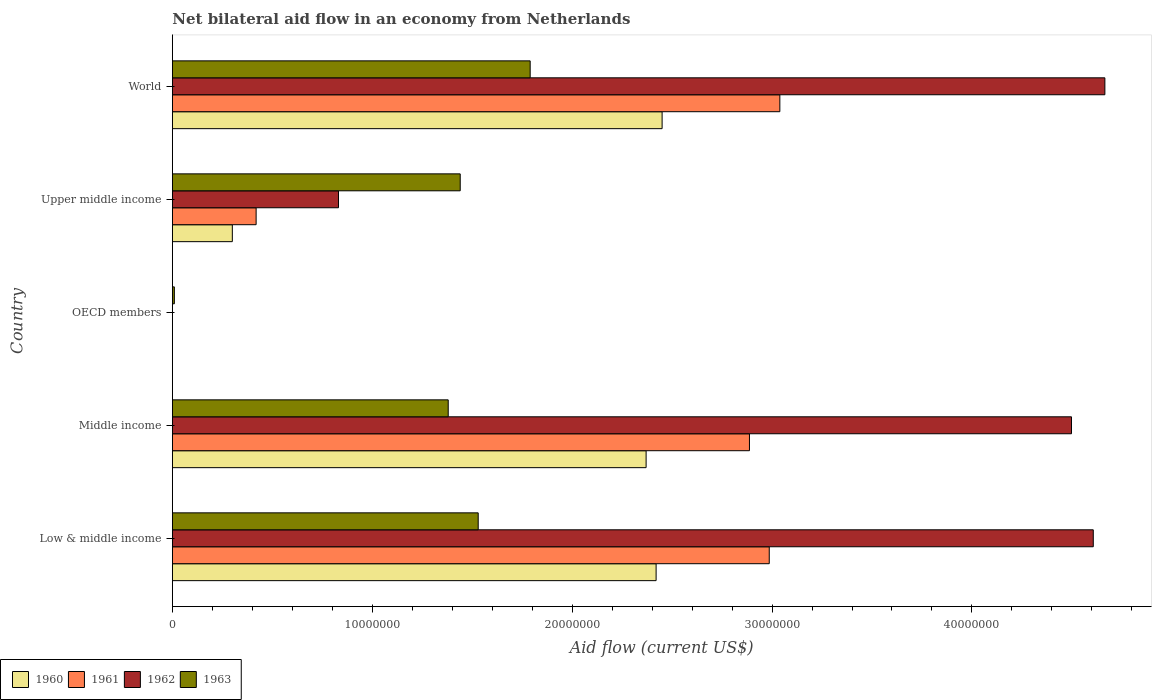How many different coloured bars are there?
Provide a short and direct response. 4. How many bars are there on the 5th tick from the top?
Your answer should be compact. 4. In how many cases, is the number of bars for a given country not equal to the number of legend labels?
Offer a very short reply. 1. What is the net bilateral aid flow in 1960 in OECD members?
Keep it short and to the point. 0. Across all countries, what is the maximum net bilateral aid flow in 1963?
Ensure brevity in your answer.  1.79e+07. Across all countries, what is the minimum net bilateral aid flow in 1963?
Ensure brevity in your answer.  1.00e+05. In which country was the net bilateral aid flow in 1963 maximum?
Provide a succinct answer. World. What is the total net bilateral aid flow in 1961 in the graph?
Give a very brief answer. 9.33e+07. What is the difference between the net bilateral aid flow in 1961 in Low & middle income and that in Middle income?
Give a very brief answer. 9.90e+05. What is the difference between the net bilateral aid flow in 1963 in World and the net bilateral aid flow in 1962 in Low & middle income?
Ensure brevity in your answer.  -2.82e+07. What is the average net bilateral aid flow in 1961 per country?
Offer a terse response. 1.87e+07. What is the difference between the net bilateral aid flow in 1963 and net bilateral aid flow in 1961 in Low & middle income?
Your answer should be compact. -1.46e+07. In how many countries, is the net bilateral aid flow in 1960 greater than 2000000 US$?
Provide a succinct answer. 4. What is the ratio of the net bilateral aid flow in 1962 in Low & middle income to that in World?
Ensure brevity in your answer.  0.99. Is the difference between the net bilateral aid flow in 1963 in Low & middle income and Middle income greater than the difference between the net bilateral aid flow in 1961 in Low & middle income and Middle income?
Keep it short and to the point. Yes. What is the difference between the highest and the second highest net bilateral aid flow in 1963?
Your answer should be compact. 2.60e+06. What is the difference between the highest and the lowest net bilateral aid flow in 1962?
Provide a short and direct response. 4.66e+07. In how many countries, is the net bilateral aid flow in 1963 greater than the average net bilateral aid flow in 1963 taken over all countries?
Offer a terse response. 4. Is the sum of the net bilateral aid flow in 1961 in Low & middle income and Middle income greater than the maximum net bilateral aid flow in 1962 across all countries?
Offer a terse response. Yes. Is it the case that in every country, the sum of the net bilateral aid flow in 1961 and net bilateral aid flow in 1960 is greater than the sum of net bilateral aid flow in 1962 and net bilateral aid flow in 1963?
Give a very brief answer. No. Is it the case that in every country, the sum of the net bilateral aid flow in 1960 and net bilateral aid flow in 1963 is greater than the net bilateral aid flow in 1961?
Offer a terse response. Yes. Are all the bars in the graph horizontal?
Your answer should be compact. Yes. How many countries are there in the graph?
Provide a succinct answer. 5. What is the difference between two consecutive major ticks on the X-axis?
Make the answer very short. 1.00e+07. Does the graph contain grids?
Provide a short and direct response. No. How many legend labels are there?
Make the answer very short. 4. How are the legend labels stacked?
Give a very brief answer. Horizontal. What is the title of the graph?
Provide a succinct answer. Net bilateral aid flow in an economy from Netherlands. What is the label or title of the Y-axis?
Ensure brevity in your answer.  Country. What is the Aid flow (current US$) in 1960 in Low & middle income?
Provide a succinct answer. 2.42e+07. What is the Aid flow (current US$) in 1961 in Low & middle income?
Your answer should be compact. 2.99e+07. What is the Aid flow (current US$) in 1962 in Low & middle income?
Keep it short and to the point. 4.61e+07. What is the Aid flow (current US$) of 1963 in Low & middle income?
Your answer should be very brief. 1.53e+07. What is the Aid flow (current US$) of 1960 in Middle income?
Keep it short and to the point. 2.37e+07. What is the Aid flow (current US$) of 1961 in Middle income?
Make the answer very short. 2.89e+07. What is the Aid flow (current US$) of 1962 in Middle income?
Give a very brief answer. 4.50e+07. What is the Aid flow (current US$) of 1963 in Middle income?
Provide a succinct answer. 1.38e+07. What is the Aid flow (current US$) in 1961 in OECD members?
Your response must be concise. 0. What is the Aid flow (current US$) in 1963 in OECD members?
Your response must be concise. 1.00e+05. What is the Aid flow (current US$) in 1960 in Upper middle income?
Give a very brief answer. 3.00e+06. What is the Aid flow (current US$) of 1961 in Upper middle income?
Offer a terse response. 4.19e+06. What is the Aid flow (current US$) in 1962 in Upper middle income?
Provide a succinct answer. 8.31e+06. What is the Aid flow (current US$) in 1963 in Upper middle income?
Offer a terse response. 1.44e+07. What is the Aid flow (current US$) in 1960 in World?
Give a very brief answer. 2.45e+07. What is the Aid flow (current US$) of 1961 in World?
Keep it short and to the point. 3.04e+07. What is the Aid flow (current US$) in 1962 in World?
Offer a very short reply. 4.66e+07. What is the Aid flow (current US$) of 1963 in World?
Ensure brevity in your answer.  1.79e+07. Across all countries, what is the maximum Aid flow (current US$) of 1960?
Provide a succinct answer. 2.45e+07. Across all countries, what is the maximum Aid flow (current US$) in 1961?
Offer a terse response. 3.04e+07. Across all countries, what is the maximum Aid flow (current US$) of 1962?
Keep it short and to the point. 4.66e+07. Across all countries, what is the maximum Aid flow (current US$) of 1963?
Provide a short and direct response. 1.79e+07. Across all countries, what is the minimum Aid flow (current US$) of 1960?
Provide a short and direct response. 0. Across all countries, what is the minimum Aid flow (current US$) in 1962?
Provide a succinct answer. 0. Across all countries, what is the minimum Aid flow (current US$) of 1963?
Offer a very short reply. 1.00e+05. What is the total Aid flow (current US$) in 1960 in the graph?
Ensure brevity in your answer.  7.54e+07. What is the total Aid flow (current US$) in 1961 in the graph?
Your answer should be very brief. 9.33e+07. What is the total Aid flow (current US$) of 1962 in the graph?
Make the answer very short. 1.46e+08. What is the total Aid flow (current US$) in 1963 in the graph?
Give a very brief answer. 6.15e+07. What is the difference between the Aid flow (current US$) of 1961 in Low & middle income and that in Middle income?
Give a very brief answer. 9.90e+05. What is the difference between the Aid flow (current US$) of 1962 in Low & middle income and that in Middle income?
Ensure brevity in your answer.  1.09e+06. What is the difference between the Aid flow (current US$) in 1963 in Low & middle income and that in Middle income?
Ensure brevity in your answer.  1.50e+06. What is the difference between the Aid flow (current US$) of 1963 in Low & middle income and that in OECD members?
Your answer should be very brief. 1.52e+07. What is the difference between the Aid flow (current US$) of 1960 in Low & middle income and that in Upper middle income?
Your answer should be compact. 2.12e+07. What is the difference between the Aid flow (current US$) in 1961 in Low & middle income and that in Upper middle income?
Provide a short and direct response. 2.57e+07. What is the difference between the Aid flow (current US$) in 1962 in Low & middle income and that in Upper middle income?
Keep it short and to the point. 3.78e+07. What is the difference between the Aid flow (current US$) of 1963 in Low & middle income and that in Upper middle income?
Offer a terse response. 9.00e+05. What is the difference between the Aid flow (current US$) in 1960 in Low & middle income and that in World?
Keep it short and to the point. -3.00e+05. What is the difference between the Aid flow (current US$) in 1961 in Low & middle income and that in World?
Your answer should be compact. -5.30e+05. What is the difference between the Aid flow (current US$) in 1962 in Low & middle income and that in World?
Your response must be concise. -5.80e+05. What is the difference between the Aid flow (current US$) of 1963 in Low & middle income and that in World?
Make the answer very short. -2.60e+06. What is the difference between the Aid flow (current US$) of 1963 in Middle income and that in OECD members?
Offer a terse response. 1.37e+07. What is the difference between the Aid flow (current US$) in 1960 in Middle income and that in Upper middle income?
Give a very brief answer. 2.07e+07. What is the difference between the Aid flow (current US$) in 1961 in Middle income and that in Upper middle income?
Provide a short and direct response. 2.47e+07. What is the difference between the Aid flow (current US$) of 1962 in Middle income and that in Upper middle income?
Make the answer very short. 3.67e+07. What is the difference between the Aid flow (current US$) of 1963 in Middle income and that in Upper middle income?
Make the answer very short. -6.00e+05. What is the difference between the Aid flow (current US$) in 1960 in Middle income and that in World?
Offer a very short reply. -8.00e+05. What is the difference between the Aid flow (current US$) in 1961 in Middle income and that in World?
Provide a short and direct response. -1.52e+06. What is the difference between the Aid flow (current US$) in 1962 in Middle income and that in World?
Your answer should be compact. -1.67e+06. What is the difference between the Aid flow (current US$) of 1963 in Middle income and that in World?
Offer a very short reply. -4.10e+06. What is the difference between the Aid flow (current US$) in 1963 in OECD members and that in Upper middle income?
Give a very brief answer. -1.43e+07. What is the difference between the Aid flow (current US$) in 1963 in OECD members and that in World?
Ensure brevity in your answer.  -1.78e+07. What is the difference between the Aid flow (current US$) in 1960 in Upper middle income and that in World?
Keep it short and to the point. -2.15e+07. What is the difference between the Aid flow (current US$) in 1961 in Upper middle income and that in World?
Provide a short and direct response. -2.62e+07. What is the difference between the Aid flow (current US$) in 1962 in Upper middle income and that in World?
Offer a terse response. -3.83e+07. What is the difference between the Aid flow (current US$) in 1963 in Upper middle income and that in World?
Your response must be concise. -3.50e+06. What is the difference between the Aid flow (current US$) in 1960 in Low & middle income and the Aid flow (current US$) in 1961 in Middle income?
Give a very brief answer. -4.67e+06. What is the difference between the Aid flow (current US$) of 1960 in Low & middle income and the Aid flow (current US$) of 1962 in Middle income?
Make the answer very short. -2.08e+07. What is the difference between the Aid flow (current US$) of 1960 in Low & middle income and the Aid flow (current US$) of 1963 in Middle income?
Offer a terse response. 1.04e+07. What is the difference between the Aid flow (current US$) of 1961 in Low & middle income and the Aid flow (current US$) of 1962 in Middle income?
Offer a very short reply. -1.51e+07. What is the difference between the Aid flow (current US$) of 1961 in Low & middle income and the Aid flow (current US$) of 1963 in Middle income?
Your answer should be compact. 1.61e+07. What is the difference between the Aid flow (current US$) of 1962 in Low & middle income and the Aid flow (current US$) of 1963 in Middle income?
Your response must be concise. 3.23e+07. What is the difference between the Aid flow (current US$) in 1960 in Low & middle income and the Aid flow (current US$) in 1963 in OECD members?
Provide a short and direct response. 2.41e+07. What is the difference between the Aid flow (current US$) in 1961 in Low & middle income and the Aid flow (current US$) in 1963 in OECD members?
Your answer should be compact. 2.98e+07. What is the difference between the Aid flow (current US$) in 1962 in Low & middle income and the Aid flow (current US$) in 1963 in OECD members?
Your answer should be very brief. 4.60e+07. What is the difference between the Aid flow (current US$) in 1960 in Low & middle income and the Aid flow (current US$) in 1961 in Upper middle income?
Offer a very short reply. 2.00e+07. What is the difference between the Aid flow (current US$) of 1960 in Low & middle income and the Aid flow (current US$) of 1962 in Upper middle income?
Give a very brief answer. 1.59e+07. What is the difference between the Aid flow (current US$) in 1960 in Low & middle income and the Aid flow (current US$) in 1963 in Upper middle income?
Keep it short and to the point. 9.80e+06. What is the difference between the Aid flow (current US$) of 1961 in Low & middle income and the Aid flow (current US$) of 1962 in Upper middle income?
Offer a terse response. 2.16e+07. What is the difference between the Aid flow (current US$) of 1961 in Low & middle income and the Aid flow (current US$) of 1963 in Upper middle income?
Ensure brevity in your answer.  1.55e+07. What is the difference between the Aid flow (current US$) in 1962 in Low & middle income and the Aid flow (current US$) in 1963 in Upper middle income?
Keep it short and to the point. 3.17e+07. What is the difference between the Aid flow (current US$) in 1960 in Low & middle income and the Aid flow (current US$) in 1961 in World?
Ensure brevity in your answer.  -6.19e+06. What is the difference between the Aid flow (current US$) in 1960 in Low & middle income and the Aid flow (current US$) in 1962 in World?
Give a very brief answer. -2.24e+07. What is the difference between the Aid flow (current US$) of 1960 in Low & middle income and the Aid flow (current US$) of 1963 in World?
Offer a very short reply. 6.30e+06. What is the difference between the Aid flow (current US$) in 1961 in Low & middle income and the Aid flow (current US$) in 1962 in World?
Provide a short and direct response. -1.68e+07. What is the difference between the Aid flow (current US$) in 1961 in Low & middle income and the Aid flow (current US$) in 1963 in World?
Provide a succinct answer. 1.20e+07. What is the difference between the Aid flow (current US$) of 1962 in Low & middle income and the Aid flow (current US$) of 1963 in World?
Make the answer very short. 2.82e+07. What is the difference between the Aid flow (current US$) in 1960 in Middle income and the Aid flow (current US$) in 1963 in OECD members?
Keep it short and to the point. 2.36e+07. What is the difference between the Aid flow (current US$) in 1961 in Middle income and the Aid flow (current US$) in 1963 in OECD members?
Your answer should be compact. 2.88e+07. What is the difference between the Aid flow (current US$) of 1962 in Middle income and the Aid flow (current US$) of 1963 in OECD members?
Give a very brief answer. 4.49e+07. What is the difference between the Aid flow (current US$) of 1960 in Middle income and the Aid flow (current US$) of 1961 in Upper middle income?
Ensure brevity in your answer.  1.95e+07. What is the difference between the Aid flow (current US$) in 1960 in Middle income and the Aid flow (current US$) in 1962 in Upper middle income?
Your answer should be compact. 1.54e+07. What is the difference between the Aid flow (current US$) in 1960 in Middle income and the Aid flow (current US$) in 1963 in Upper middle income?
Ensure brevity in your answer.  9.30e+06. What is the difference between the Aid flow (current US$) of 1961 in Middle income and the Aid flow (current US$) of 1962 in Upper middle income?
Your response must be concise. 2.06e+07. What is the difference between the Aid flow (current US$) in 1961 in Middle income and the Aid flow (current US$) in 1963 in Upper middle income?
Your answer should be compact. 1.45e+07. What is the difference between the Aid flow (current US$) in 1962 in Middle income and the Aid flow (current US$) in 1963 in Upper middle income?
Ensure brevity in your answer.  3.06e+07. What is the difference between the Aid flow (current US$) in 1960 in Middle income and the Aid flow (current US$) in 1961 in World?
Give a very brief answer. -6.69e+06. What is the difference between the Aid flow (current US$) of 1960 in Middle income and the Aid flow (current US$) of 1962 in World?
Your answer should be compact. -2.30e+07. What is the difference between the Aid flow (current US$) of 1960 in Middle income and the Aid flow (current US$) of 1963 in World?
Offer a very short reply. 5.80e+06. What is the difference between the Aid flow (current US$) in 1961 in Middle income and the Aid flow (current US$) in 1962 in World?
Offer a very short reply. -1.78e+07. What is the difference between the Aid flow (current US$) of 1961 in Middle income and the Aid flow (current US$) of 1963 in World?
Ensure brevity in your answer.  1.10e+07. What is the difference between the Aid flow (current US$) in 1962 in Middle income and the Aid flow (current US$) in 1963 in World?
Offer a very short reply. 2.71e+07. What is the difference between the Aid flow (current US$) of 1960 in Upper middle income and the Aid flow (current US$) of 1961 in World?
Offer a terse response. -2.74e+07. What is the difference between the Aid flow (current US$) of 1960 in Upper middle income and the Aid flow (current US$) of 1962 in World?
Your answer should be compact. -4.36e+07. What is the difference between the Aid flow (current US$) in 1960 in Upper middle income and the Aid flow (current US$) in 1963 in World?
Offer a terse response. -1.49e+07. What is the difference between the Aid flow (current US$) in 1961 in Upper middle income and the Aid flow (current US$) in 1962 in World?
Make the answer very short. -4.25e+07. What is the difference between the Aid flow (current US$) in 1961 in Upper middle income and the Aid flow (current US$) in 1963 in World?
Your answer should be compact. -1.37e+07. What is the difference between the Aid flow (current US$) in 1962 in Upper middle income and the Aid flow (current US$) in 1963 in World?
Offer a terse response. -9.59e+06. What is the average Aid flow (current US$) in 1960 per country?
Offer a very short reply. 1.51e+07. What is the average Aid flow (current US$) in 1961 per country?
Provide a short and direct response. 1.87e+07. What is the average Aid flow (current US$) of 1962 per country?
Offer a very short reply. 2.92e+07. What is the average Aid flow (current US$) in 1963 per country?
Make the answer very short. 1.23e+07. What is the difference between the Aid flow (current US$) of 1960 and Aid flow (current US$) of 1961 in Low & middle income?
Your answer should be compact. -5.66e+06. What is the difference between the Aid flow (current US$) of 1960 and Aid flow (current US$) of 1962 in Low & middle income?
Provide a short and direct response. -2.19e+07. What is the difference between the Aid flow (current US$) in 1960 and Aid flow (current US$) in 1963 in Low & middle income?
Your answer should be very brief. 8.90e+06. What is the difference between the Aid flow (current US$) in 1961 and Aid flow (current US$) in 1962 in Low & middle income?
Offer a very short reply. -1.62e+07. What is the difference between the Aid flow (current US$) in 1961 and Aid flow (current US$) in 1963 in Low & middle income?
Offer a terse response. 1.46e+07. What is the difference between the Aid flow (current US$) of 1962 and Aid flow (current US$) of 1963 in Low & middle income?
Ensure brevity in your answer.  3.08e+07. What is the difference between the Aid flow (current US$) in 1960 and Aid flow (current US$) in 1961 in Middle income?
Make the answer very short. -5.17e+06. What is the difference between the Aid flow (current US$) in 1960 and Aid flow (current US$) in 1962 in Middle income?
Offer a terse response. -2.13e+07. What is the difference between the Aid flow (current US$) in 1960 and Aid flow (current US$) in 1963 in Middle income?
Offer a terse response. 9.90e+06. What is the difference between the Aid flow (current US$) of 1961 and Aid flow (current US$) of 1962 in Middle income?
Your answer should be very brief. -1.61e+07. What is the difference between the Aid flow (current US$) of 1961 and Aid flow (current US$) of 1963 in Middle income?
Your answer should be compact. 1.51e+07. What is the difference between the Aid flow (current US$) of 1962 and Aid flow (current US$) of 1963 in Middle income?
Give a very brief answer. 3.12e+07. What is the difference between the Aid flow (current US$) of 1960 and Aid flow (current US$) of 1961 in Upper middle income?
Give a very brief answer. -1.19e+06. What is the difference between the Aid flow (current US$) in 1960 and Aid flow (current US$) in 1962 in Upper middle income?
Offer a very short reply. -5.31e+06. What is the difference between the Aid flow (current US$) in 1960 and Aid flow (current US$) in 1963 in Upper middle income?
Your answer should be compact. -1.14e+07. What is the difference between the Aid flow (current US$) of 1961 and Aid flow (current US$) of 1962 in Upper middle income?
Offer a terse response. -4.12e+06. What is the difference between the Aid flow (current US$) of 1961 and Aid flow (current US$) of 1963 in Upper middle income?
Provide a succinct answer. -1.02e+07. What is the difference between the Aid flow (current US$) in 1962 and Aid flow (current US$) in 1963 in Upper middle income?
Your answer should be very brief. -6.09e+06. What is the difference between the Aid flow (current US$) of 1960 and Aid flow (current US$) of 1961 in World?
Keep it short and to the point. -5.89e+06. What is the difference between the Aid flow (current US$) in 1960 and Aid flow (current US$) in 1962 in World?
Provide a succinct answer. -2.22e+07. What is the difference between the Aid flow (current US$) of 1960 and Aid flow (current US$) of 1963 in World?
Your answer should be very brief. 6.60e+06. What is the difference between the Aid flow (current US$) of 1961 and Aid flow (current US$) of 1962 in World?
Offer a terse response. -1.63e+07. What is the difference between the Aid flow (current US$) of 1961 and Aid flow (current US$) of 1963 in World?
Offer a very short reply. 1.25e+07. What is the difference between the Aid flow (current US$) in 1962 and Aid flow (current US$) in 1963 in World?
Ensure brevity in your answer.  2.88e+07. What is the ratio of the Aid flow (current US$) in 1960 in Low & middle income to that in Middle income?
Your answer should be very brief. 1.02. What is the ratio of the Aid flow (current US$) in 1961 in Low & middle income to that in Middle income?
Offer a terse response. 1.03. What is the ratio of the Aid flow (current US$) of 1962 in Low & middle income to that in Middle income?
Provide a short and direct response. 1.02. What is the ratio of the Aid flow (current US$) in 1963 in Low & middle income to that in Middle income?
Offer a very short reply. 1.11. What is the ratio of the Aid flow (current US$) of 1963 in Low & middle income to that in OECD members?
Your answer should be compact. 153. What is the ratio of the Aid flow (current US$) in 1960 in Low & middle income to that in Upper middle income?
Ensure brevity in your answer.  8.07. What is the ratio of the Aid flow (current US$) in 1961 in Low & middle income to that in Upper middle income?
Provide a short and direct response. 7.13. What is the ratio of the Aid flow (current US$) in 1962 in Low & middle income to that in Upper middle income?
Give a very brief answer. 5.54. What is the ratio of the Aid flow (current US$) in 1961 in Low & middle income to that in World?
Make the answer very short. 0.98. What is the ratio of the Aid flow (current US$) of 1962 in Low & middle income to that in World?
Your answer should be compact. 0.99. What is the ratio of the Aid flow (current US$) of 1963 in Low & middle income to that in World?
Keep it short and to the point. 0.85. What is the ratio of the Aid flow (current US$) in 1963 in Middle income to that in OECD members?
Offer a very short reply. 138. What is the ratio of the Aid flow (current US$) of 1961 in Middle income to that in Upper middle income?
Your answer should be compact. 6.89. What is the ratio of the Aid flow (current US$) in 1962 in Middle income to that in Upper middle income?
Offer a very short reply. 5.41. What is the ratio of the Aid flow (current US$) in 1963 in Middle income to that in Upper middle income?
Your answer should be compact. 0.96. What is the ratio of the Aid flow (current US$) in 1960 in Middle income to that in World?
Your response must be concise. 0.97. What is the ratio of the Aid flow (current US$) in 1962 in Middle income to that in World?
Your response must be concise. 0.96. What is the ratio of the Aid flow (current US$) of 1963 in Middle income to that in World?
Your answer should be compact. 0.77. What is the ratio of the Aid flow (current US$) in 1963 in OECD members to that in Upper middle income?
Provide a short and direct response. 0.01. What is the ratio of the Aid flow (current US$) in 1963 in OECD members to that in World?
Provide a succinct answer. 0.01. What is the ratio of the Aid flow (current US$) in 1960 in Upper middle income to that in World?
Provide a short and direct response. 0.12. What is the ratio of the Aid flow (current US$) of 1961 in Upper middle income to that in World?
Your answer should be very brief. 0.14. What is the ratio of the Aid flow (current US$) in 1962 in Upper middle income to that in World?
Your answer should be very brief. 0.18. What is the ratio of the Aid flow (current US$) in 1963 in Upper middle income to that in World?
Your answer should be very brief. 0.8. What is the difference between the highest and the second highest Aid flow (current US$) in 1960?
Your response must be concise. 3.00e+05. What is the difference between the highest and the second highest Aid flow (current US$) in 1961?
Offer a very short reply. 5.30e+05. What is the difference between the highest and the second highest Aid flow (current US$) of 1962?
Offer a very short reply. 5.80e+05. What is the difference between the highest and the second highest Aid flow (current US$) of 1963?
Offer a terse response. 2.60e+06. What is the difference between the highest and the lowest Aid flow (current US$) of 1960?
Offer a very short reply. 2.45e+07. What is the difference between the highest and the lowest Aid flow (current US$) of 1961?
Offer a very short reply. 3.04e+07. What is the difference between the highest and the lowest Aid flow (current US$) in 1962?
Your response must be concise. 4.66e+07. What is the difference between the highest and the lowest Aid flow (current US$) in 1963?
Give a very brief answer. 1.78e+07. 